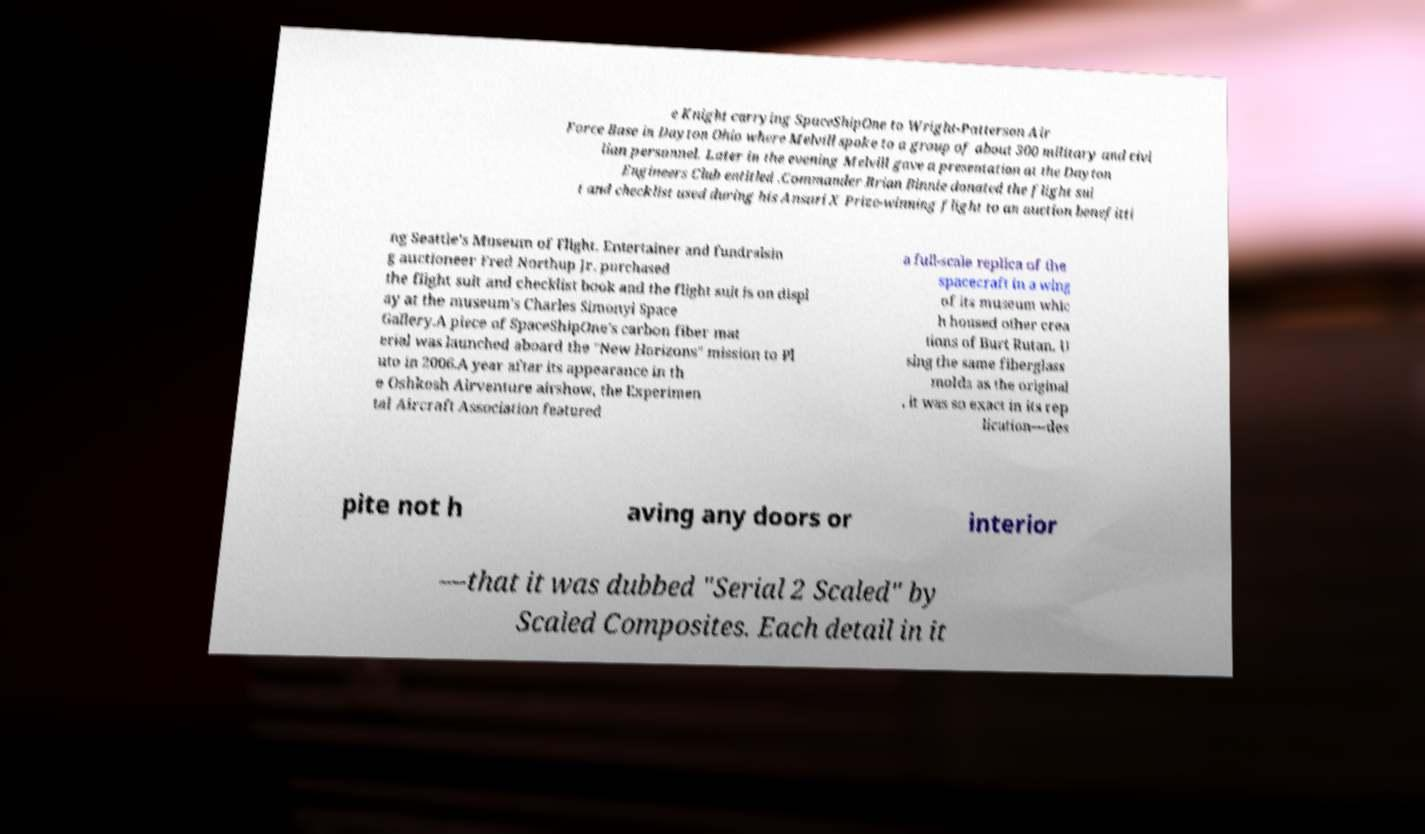Please identify and transcribe the text found in this image. e Knight carrying SpaceShipOne to Wright-Patterson Air Force Base in Dayton Ohio where Melvill spoke to a group of about 300 military and civi lian personnel. Later in the evening Melvill gave a presentation at the Dayton Engineers Club entitled .Commander Brian Binnie donated the flight sui t and checklist used during his Ansari X Prize-winning flight to an auction benefitti ng Seattle's Museum of Flight. Entertainer and fundraisin g auctioneer Fred Northup Jr. purchased the flight suit and checklist book and the flight suit is on displ ay at the museum's Charles Simonyi Space Gallery.A piece of SpaceShipOne's carbon fiber mat erial was launched aboard the "New Horizons" mission to Pl uto in 2006.A year after its appearance in th e Oshkosh Airventure airshow, the Experimen tal Aircraft Association featured a full-scale replica of the spacecraft in a wing of its museum whic h housed other crea tions of Burt Rutan. U sing the same fiberglass molds as the original , it was so exact in its rep lication—des pite not h aving any doors or interior —that it was dubbed "Serial 2 Scaled" by Scaled Composites. Each detail in it 